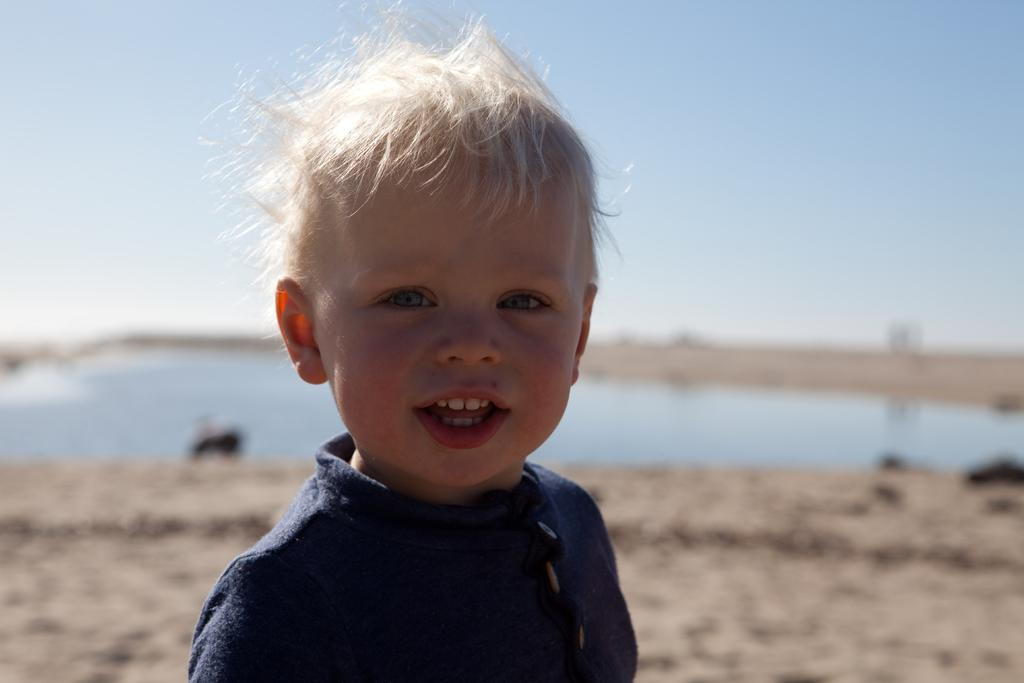What is the main subject of the image? There is a child in the image. What is the child wearing? The child is wearing a blue dress. What can be seen in the background of the image? There is ground, water, black colored objects, and the sky visible in the background of the image. What type of suit can be seen hanging in the background of the image? There is no suit present in the image; the child is wearing a blue dress, and the background features ground, water, black colored objects, and the sky. 